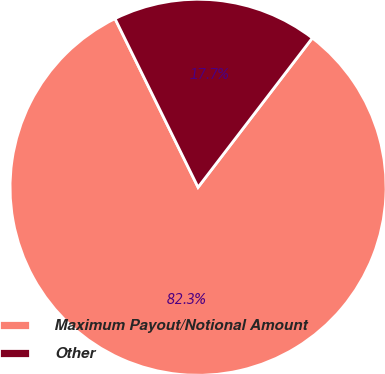<chart> <loc_0><loc_0><loc_500><loc_500><pie_chart><fcel>Maximum Payout/Notional Amount<fcel>Other<nl><fcel>82.32%<fcel>17.68%<nl></chart> 